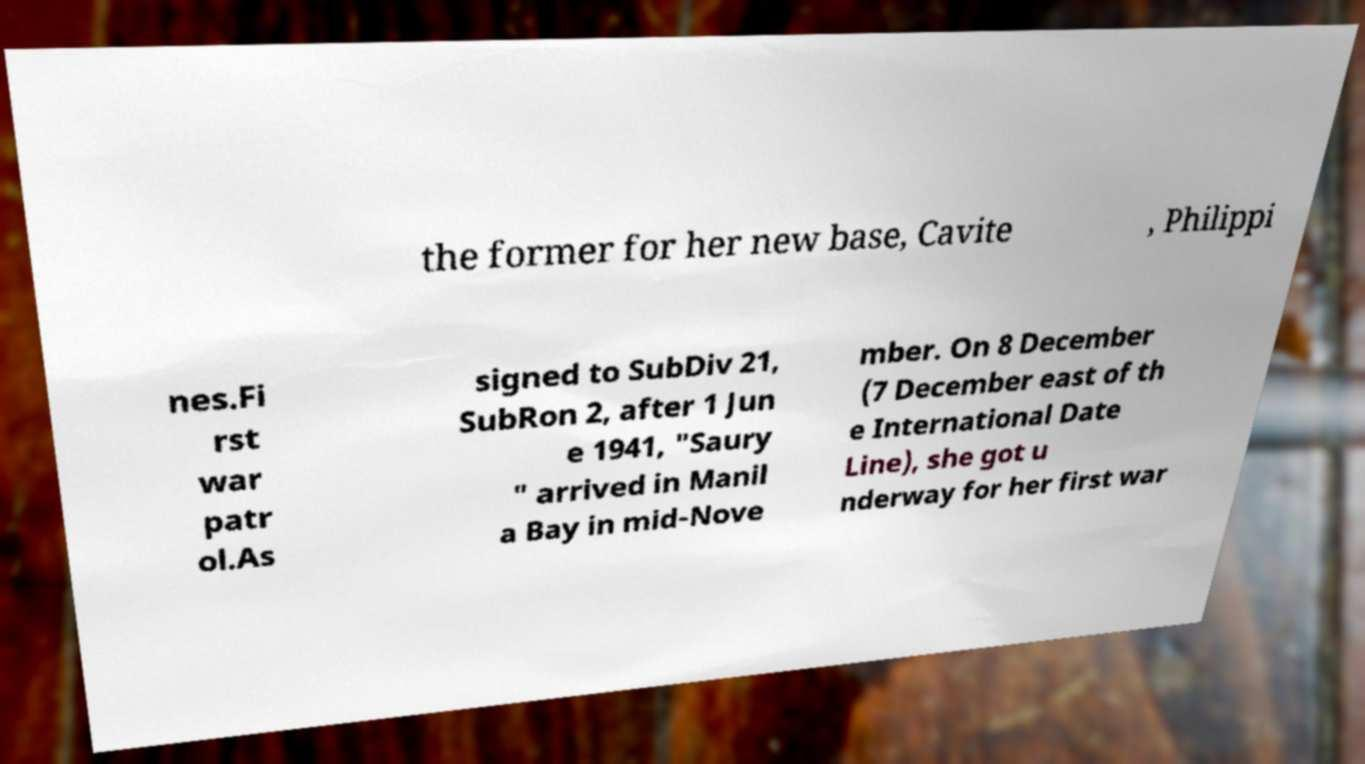What messages or text are displayed in this image? I need them in a readable, typed format. the former for her new base, Cavite , Philippi nes.Fi rst war patr ol.As signed to SubDiv 21, SubRon 2, after 1 Jun e 1941, "Saury " arrived in Manil a Bay in mid-Nove mber. On 8 December (7 December east of th e International Date Line), she got u nderway for her first war 